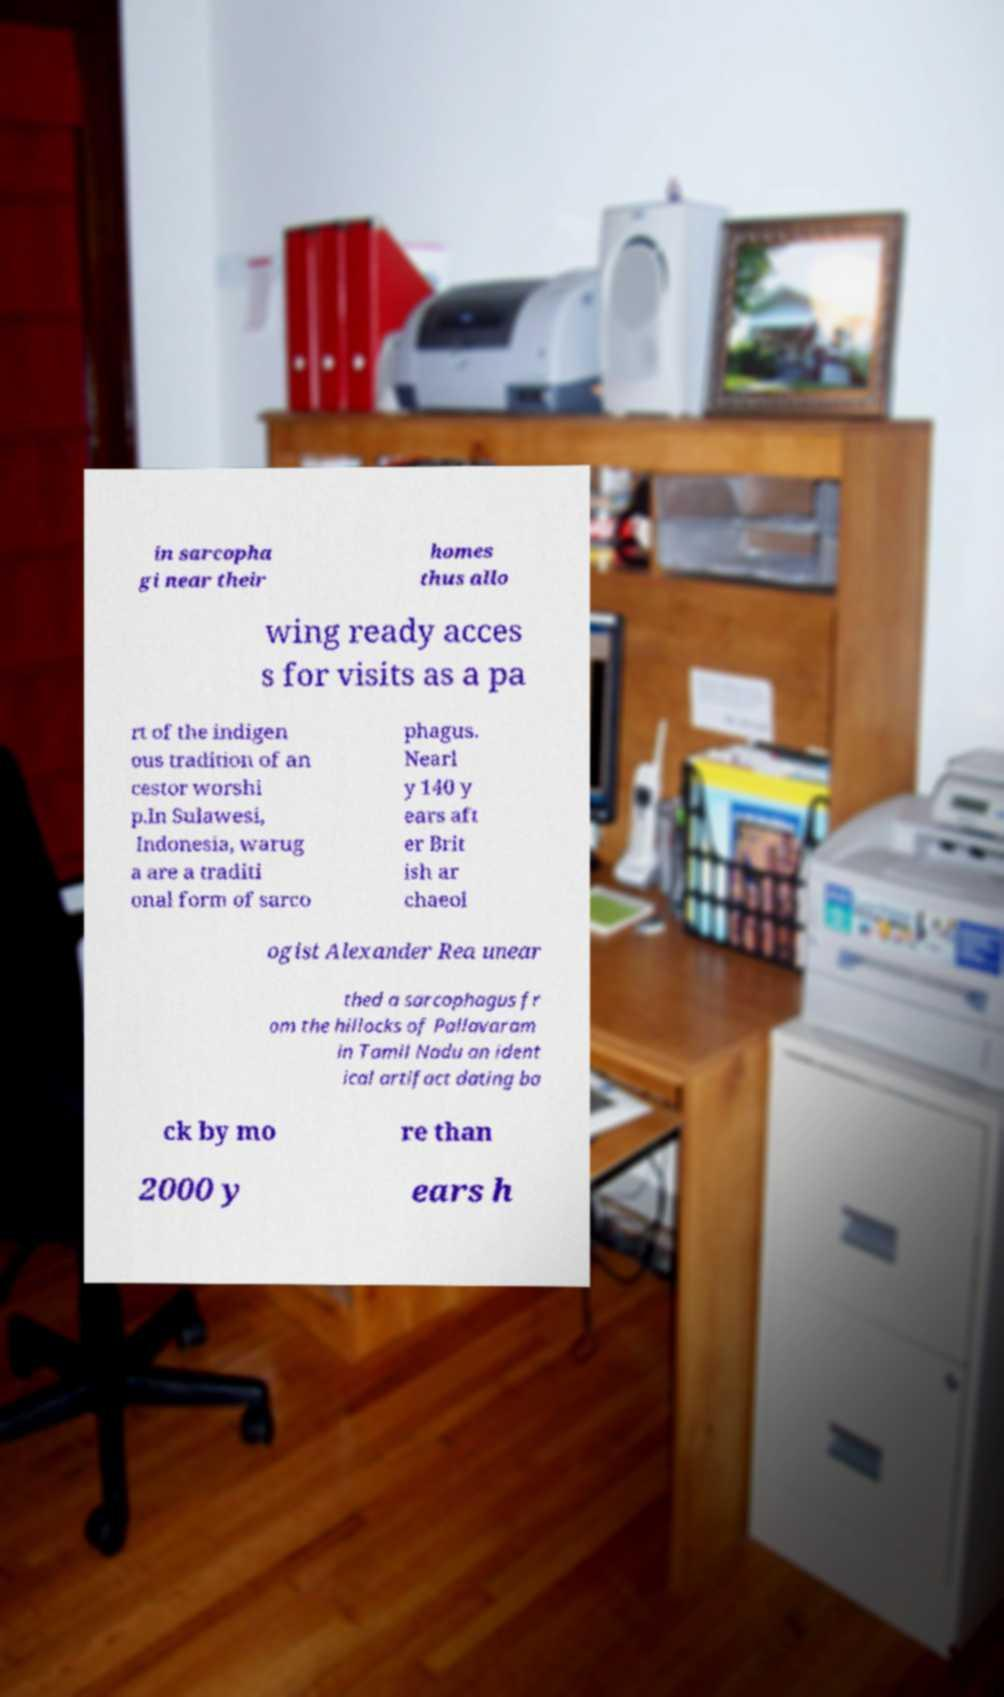For documentation purposes, I need the text within this image transcribed. Could you provide that? in sarcopha gi near their homes thus allo wing ready acces s for visits as a pa rt of the indigen ous tradition of an cestor worshi p.In Sulawesi, Indonesia, warug a are a traditi onal form of sarco phagus. Nearl y 140 y ears aft er Brit ish ar chaeol ogist Alexander Rea unear thed a sarcophagus fr om the hillocks of Pallavaram in Tamil Nadu an ident ical artifact dating ba ck by mo re than 2000 y ears h 